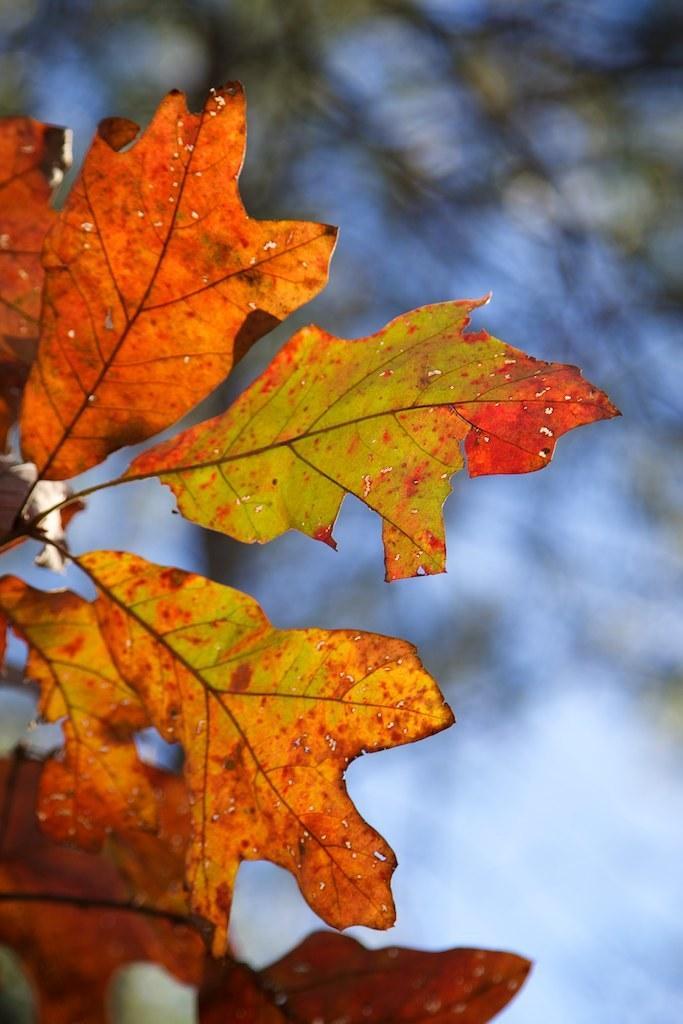In one or two sentences, can you explain what this image depicts? In this image I can see few dried leaves in orange and green color. In the background I can see few trees in green color and the sky is in blue color. 